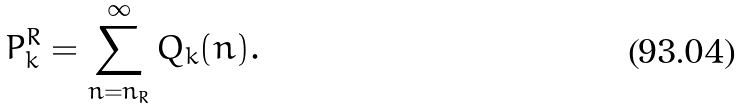Convert formula to latex. <formula><loc_0><loc_0><loc_500><loc_500>P ^ { R } _ { k } = \sum _ { n = n _ { R } } ^ { \infty } Q _ { k } ( n ) .</formula> 